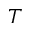<formula> <loc_0><loc_0><loc_500><loc_500>T</formula> 